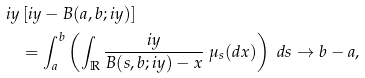Convert formula to latex. <formula><loc_0><loc_0><loc_500><loc_500>i y & \left [ i y - B ( a , b ; i y ) \right ] \\ & = \int _ { a } ^ { b } \left ( \int _ { \mathbb { R } } \frac { i y } { B ( s , b ; i y ) - x } \ \mu _ { s } ( d x ) \right ) \ d s \to b - a ,</formula> 